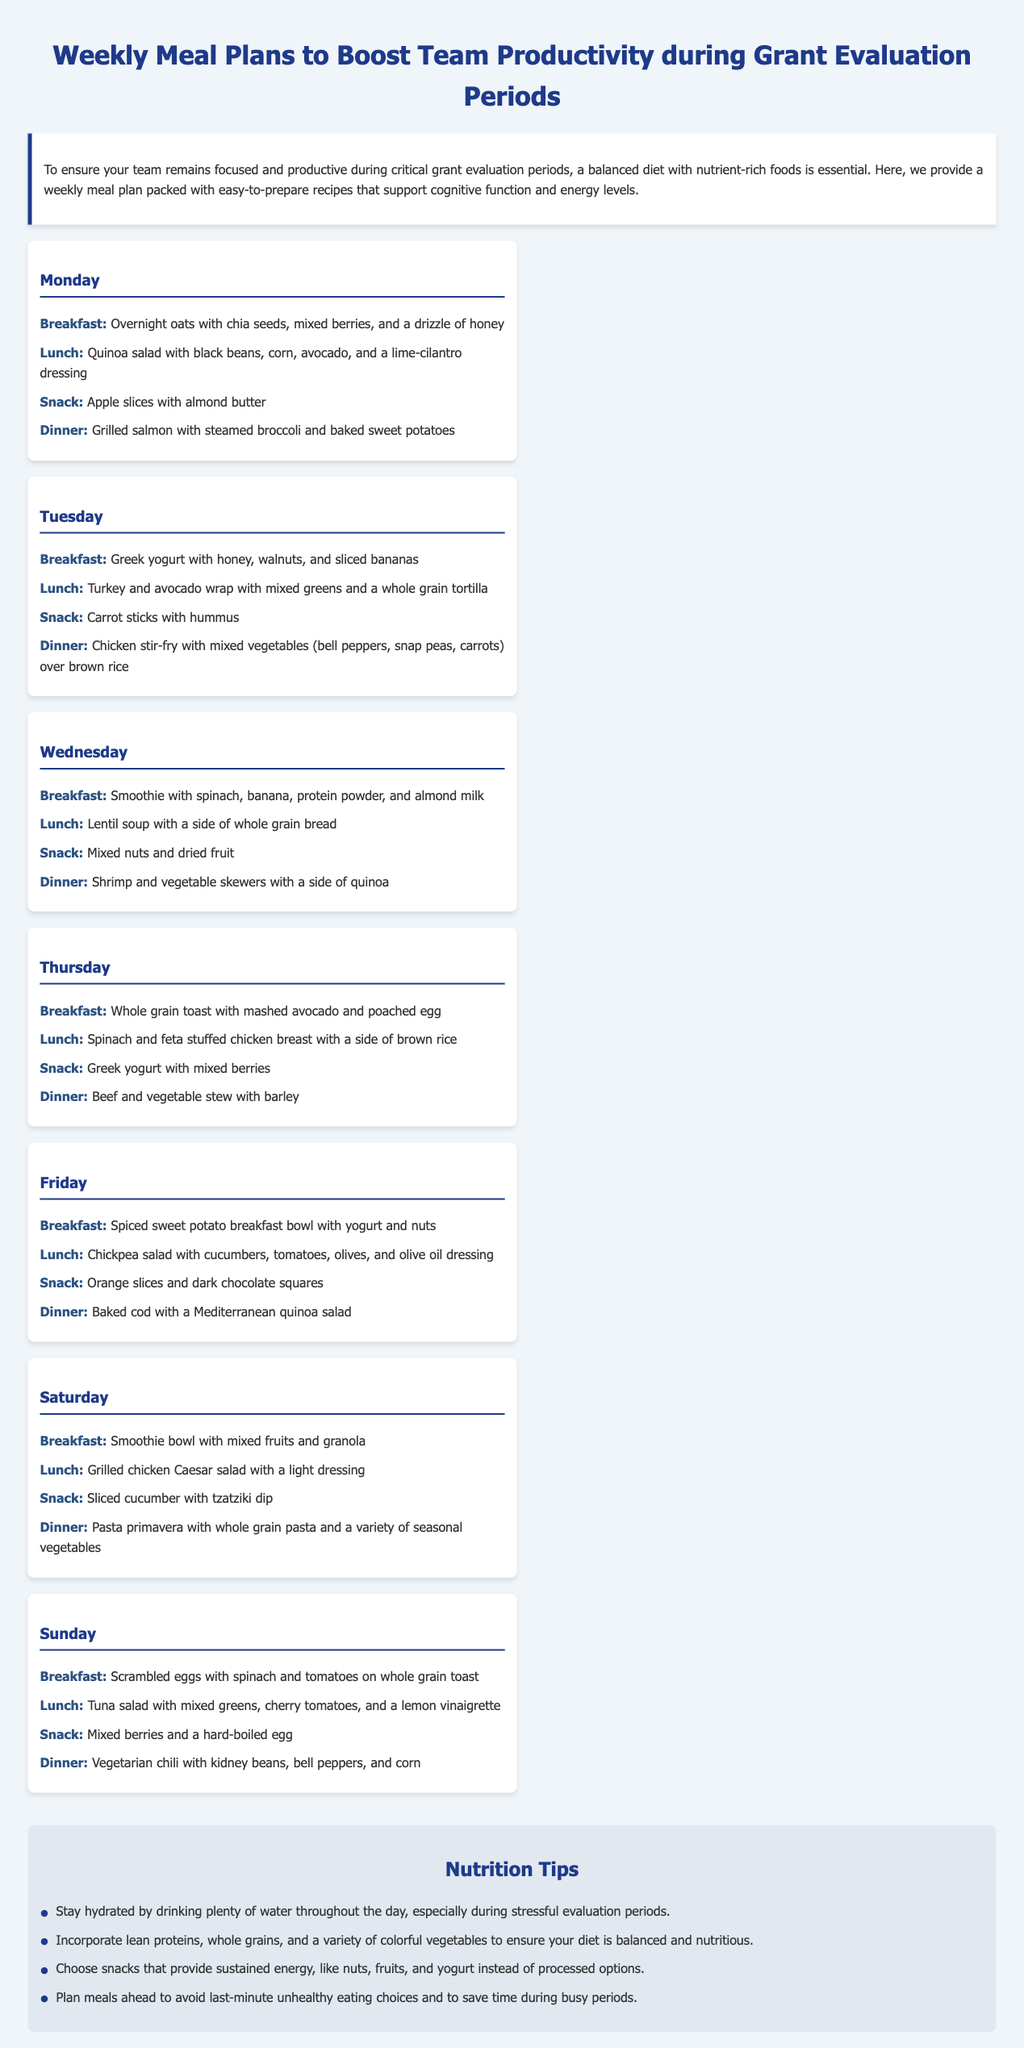What is the title of the document? The title is located in the header of the document, which states the purpose of the content.
Answer: Weekly Meal Plans to Boost Team Productivity during Grant Evaluation Periods How many meal plans are provided for each day? The meal plans section contains entries for breakfast, lunch, snack, and dinner for each day, with a total of four meals listed per day.
Answer: Four What is Monday's dinner meal? The dinner meal for Monday is listed under the Monday section of the meal plan.
Answer: Grilled salmon with steamed broccoli and baked sweet potatoes Which day has a breakfast of scrambled eggs with spinach and tomatoes? This breakfast is specified in the Sunday section of the meal plan, indicating which meals are planned for that day.
Answer: Sunday What is a suggested snack for Tuesday? The snack for Tuesday is found in the Tuesday section of the meal plan; it indicates healthy snack options for the day.
Answer: Carrot sticks with hummus What does the meal plan recommend for Wednesday's lunch? The lunch recommendation is located under the Wednesday section, indicating the meal choice provided for that day.
Answer: Lentil soup with a side of whole grain bread What type of meal is suggested for Saturday's dinner? The type of meal for Saturday's dinner can be found under the Saturday section, indicating what will be served for that meal time.
Answer: Pasta primavera with whole grain pasta and a variety of seasonal vegetables What is one nutrition tip mentioned in the document? The nutrition tips are included in a specific section at the bottom of the document, summarizing key advice for maintaining a healthy diet.
Answer: Stay hydrated by drinking plenty of water throughout the day, especially during stressful evaluation periods 